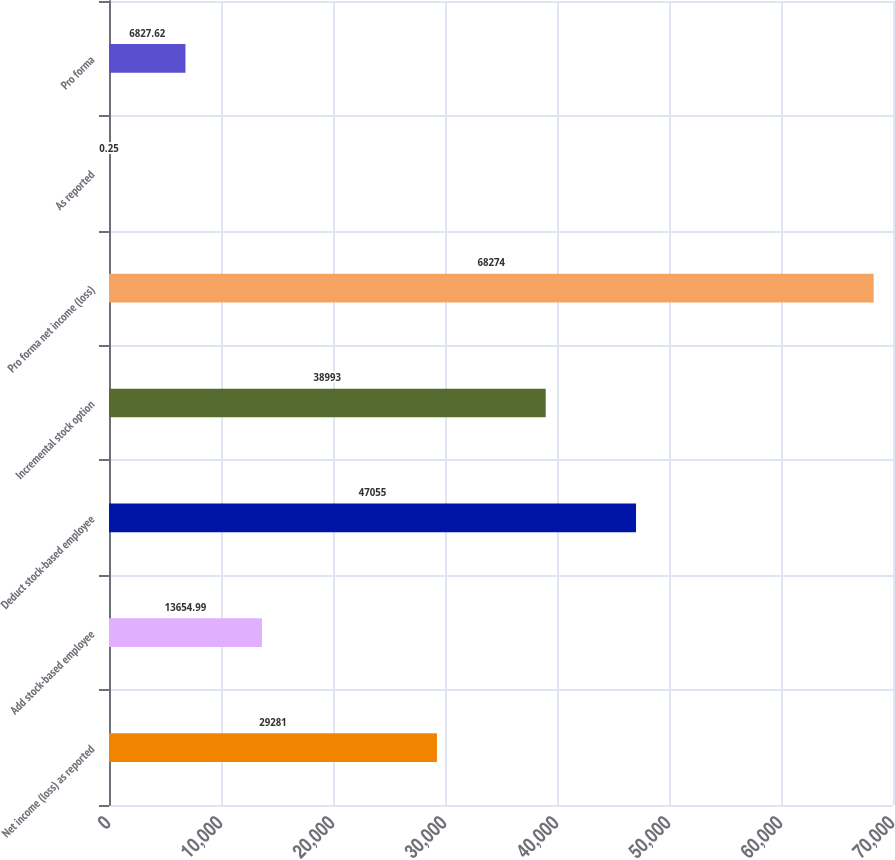Convert chart to OTSL. <chart><loc_0><loc_0><loc_500><loc_500><bar_chart><fcel>Net income (loss) as reported<fcel>Add stock-based employee<fcel>Deduct stock-based employee<fcel>Incremental stock option<fcel>Pro forma net income (loss)<fcel>As reported<fcel>Pro forma<nl><fcel>29281<fcel>13655<fcel>47055<fcel>38993<fcel>68274<fcel>0.25<fcel>6827.62<nl></chart> 